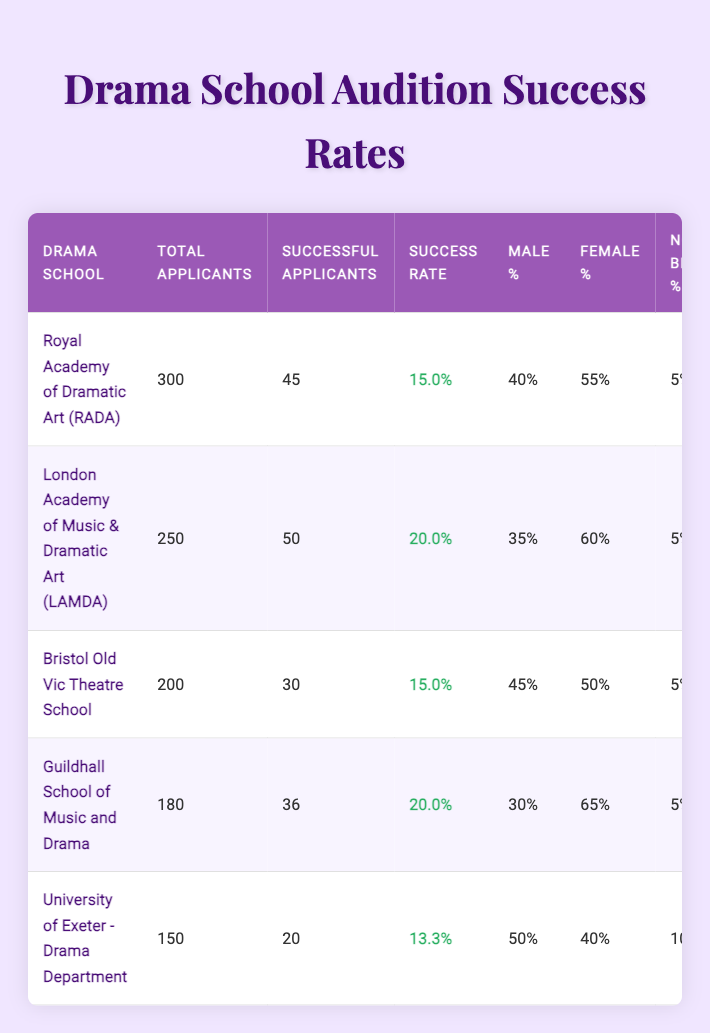What is the success rate for the Royal Academy of Dramatic Art (RADA)? The success rate can be found in the table under the RADA row. It states that the success rate is 15.0%.
Answer: 15.0% Which drama school has the highest percentage of female applicants? Looking at the table, the Guildhall School of Music and Drama has 65% female applicants, which is the highest among all schools listed.
Answer: Guildhall School of Music and Drama What is the average age of successful applicants at the London Academy of Music & Dramatic Art (LAMDA)? The table states that the average age of successful applicants at LAMDA is 22.
Answer: 22 Which school has the lowest overall success rate, and what is that rate? By evaluating the success rates, the University of Exeter - Drama Department has a success rate of 13.3%, which is the lowest compared to the other drama schools listed.
Answer: University of Exeter - Drama Department, 13.3% Is the ethnic diversity percentage at the Bristol Old Vic Theatre School above 20%? The table indicates that the ethnic diversity percentage at Bristol Old Vic Theatre School is 20%, which is not above 20%. Thus, the statement is false.
Answer: No Calculate the total number of successful applicants across all listed drama schools. To find this, we add the successful applicants from each row: 45 (RADA) + 50 (LAMDA) + 30 (Bristol) + 36 (Guildhall) + 20 (Exeter) = 181.
Answer: 181 What is the percentage of non-binary applicants at the University of Exeter - Drama Department compared to RADA? The University of Exeter has 10% non-binary applicants while RADA has 5%. Thus, Exeter has a higher percentage than RADA.
Answer: Yes What is the average success rate of all five drama schools? First, we sum the success rates: 15.0% + 20.0% + 15.0% + 20.0% + 13.3% = 83.3%. Next, we divide by 5 to get the average: 83.3/5 = 16.66%.
Answer: 16.66% 